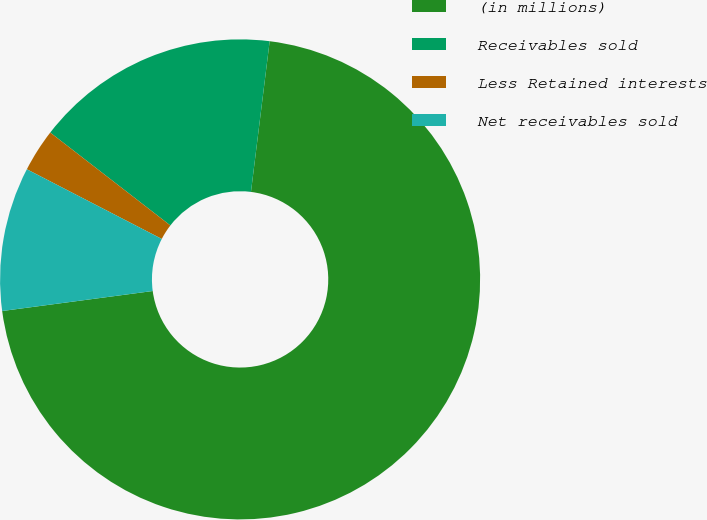Convert chart to OTSL. <chart><loc_0><loc_0><loc_500><loc_500><pie_chart><fcel>(in millions)<fcel>Receivables sold<fcel>Less Retained interests<fcel>Net receivables sold<nl><fcel>70.93%<fcel>16.49%<fcel>2.89%<fcel>9.69%<nl></chart> 